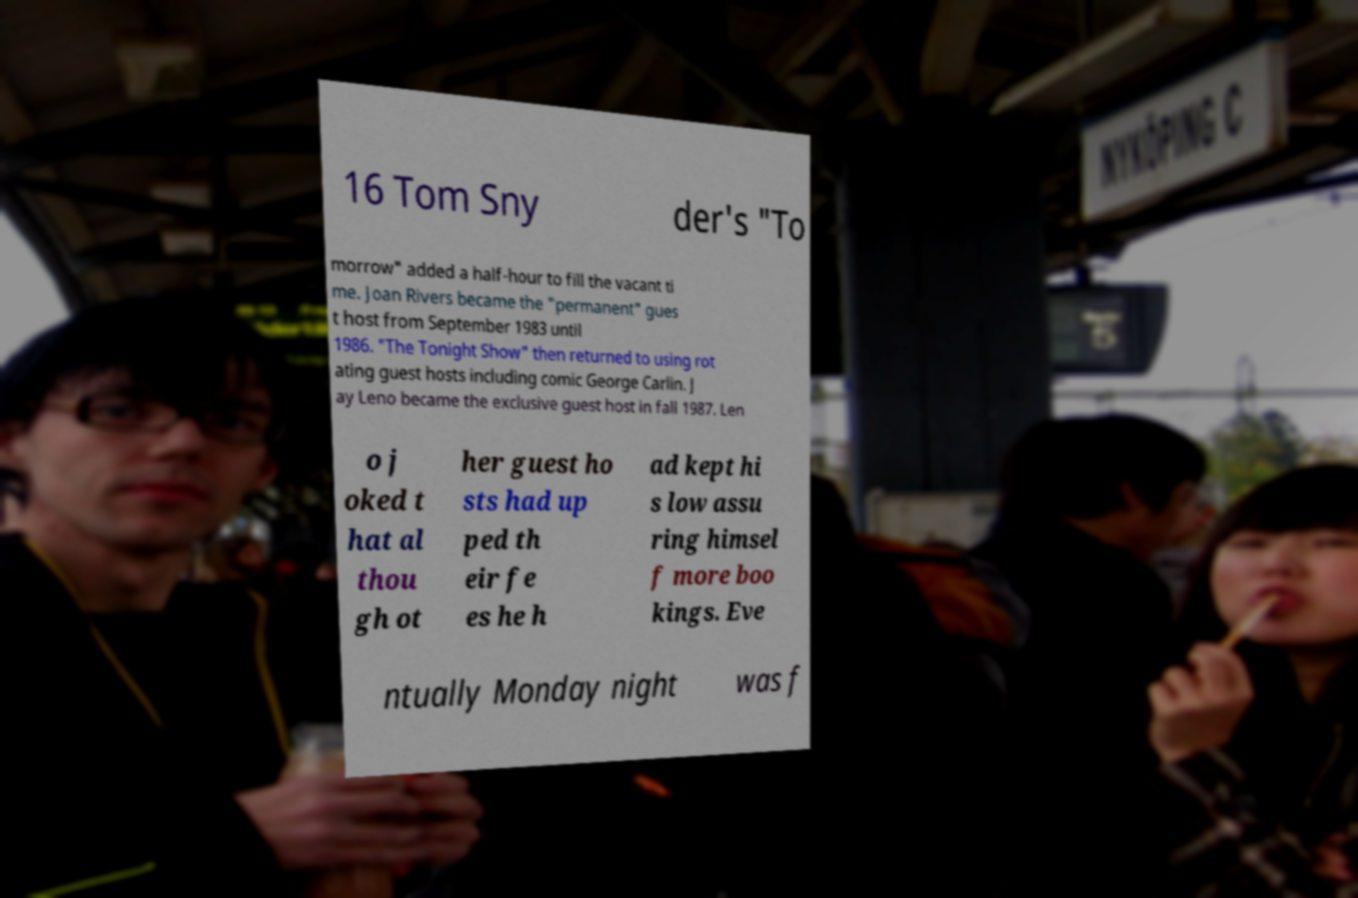Could you assist in decoding the text presented in this image and type it out clearly? 16 Tom Sny der's "To morrow" added a half-hour to fill the vacant ti me. Joan Rivers became the "permanent" gues t host from September 1983 until 1986. "The Tonight Show" then returned to using rot ating guest hosts including comic George Carlin. J ay Leno became the exclusive guest host in fall 1987. Len o j oked t hat al thou gh ot her guest ho sts had up ped th eir fe es he h ad kept hi s low assu ring himsel f more boo kings. Eve ntually Monday night was f 